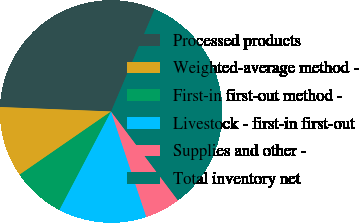<chart> <loc_0><loc_0><loc_500><loc_500><pie_chart><fcel>Processed products<fcel>Weighted-average method -<fcel>First-in first-out method -<fcel>Livestock - first-in first-out<fcel>Supplies and other -<fcel>Total inventory net<nl><fcel>30.77%<fcel>10.26%<fcel>7.69%<fcel>12.82%<fcel>5.13%<fcel>33.33%<nl></chart> 